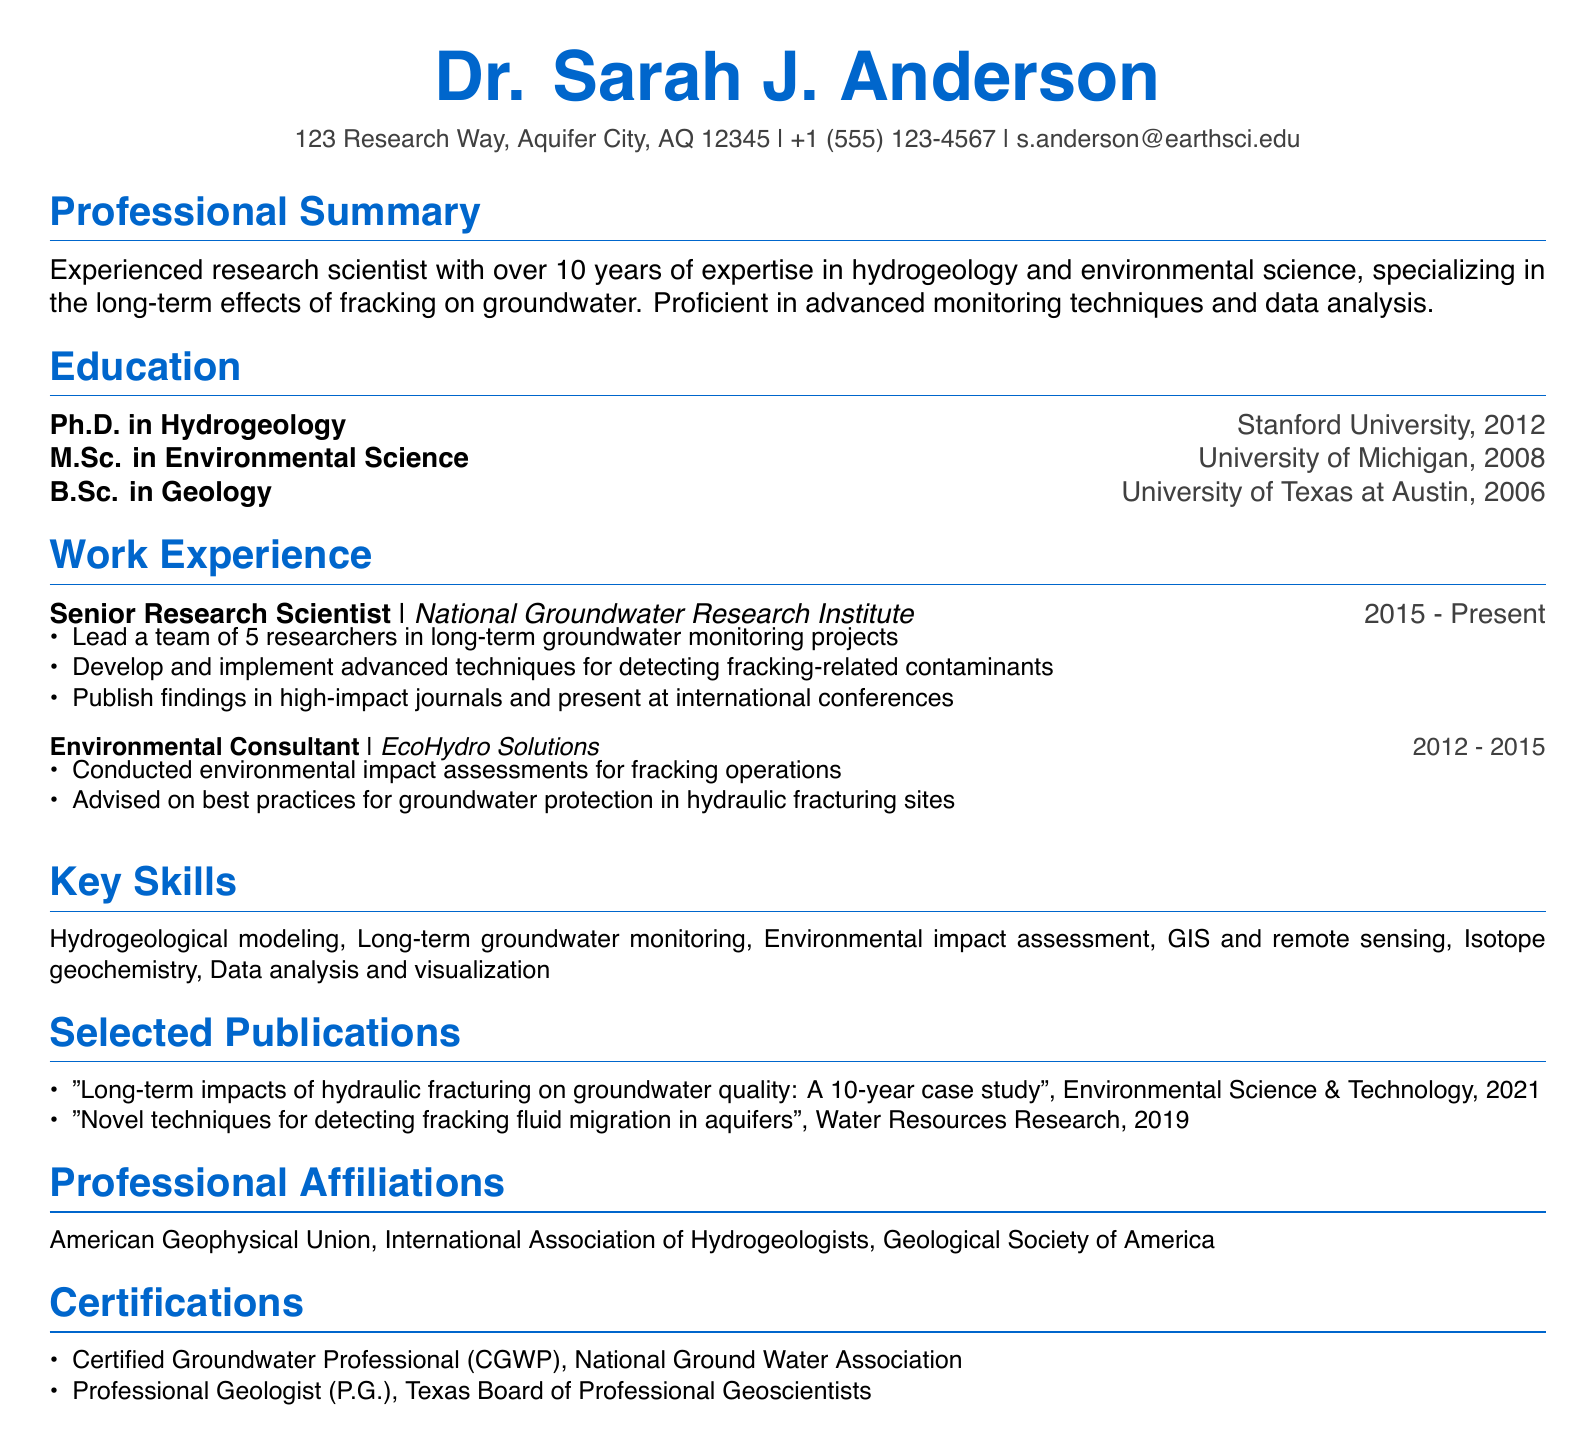what is Dr. Sarah J. Anderson's email address? The email address is listed in the contact section of the document.
Answer: s.anderson@earthsci.edu what year did Dr. Anderson complete her Ph.D.? The document states the year of the Ph.D. completion in the education section.
Answer: 2012 what is the title of Dr. Anderson's publication in 2021? The title is mentioned under the publications section along with the publication year.
Answer: Long-term impacts of hydraulic fracturing on groundwater quality: A 10-year case study how many years of experience does Dr. Anderson have in her field? The professional summary mentions having over 10 years of expertise.
Answer: over 10 years what organization has Dr. Anderson been working with since 2015? The current position section specifies the organization where she works.
Answer: National Groundwater Research Institute which degree did Dr. Anderson obtain from the University of Michigan? The education section lists degrees with their respective institutions.
Answer: M.Sc. in Environmental Science how many researchers does Dr. Anderson lead in her current position? The document specifies the number of researchers she leads in her responsibilities.
Answer: 5 what certification does Dr. Anderson have from the National Ground Water Association? The certifications section contains specific credentials she holds.
Answer: Certified Groundwater Professional (CGWP) 